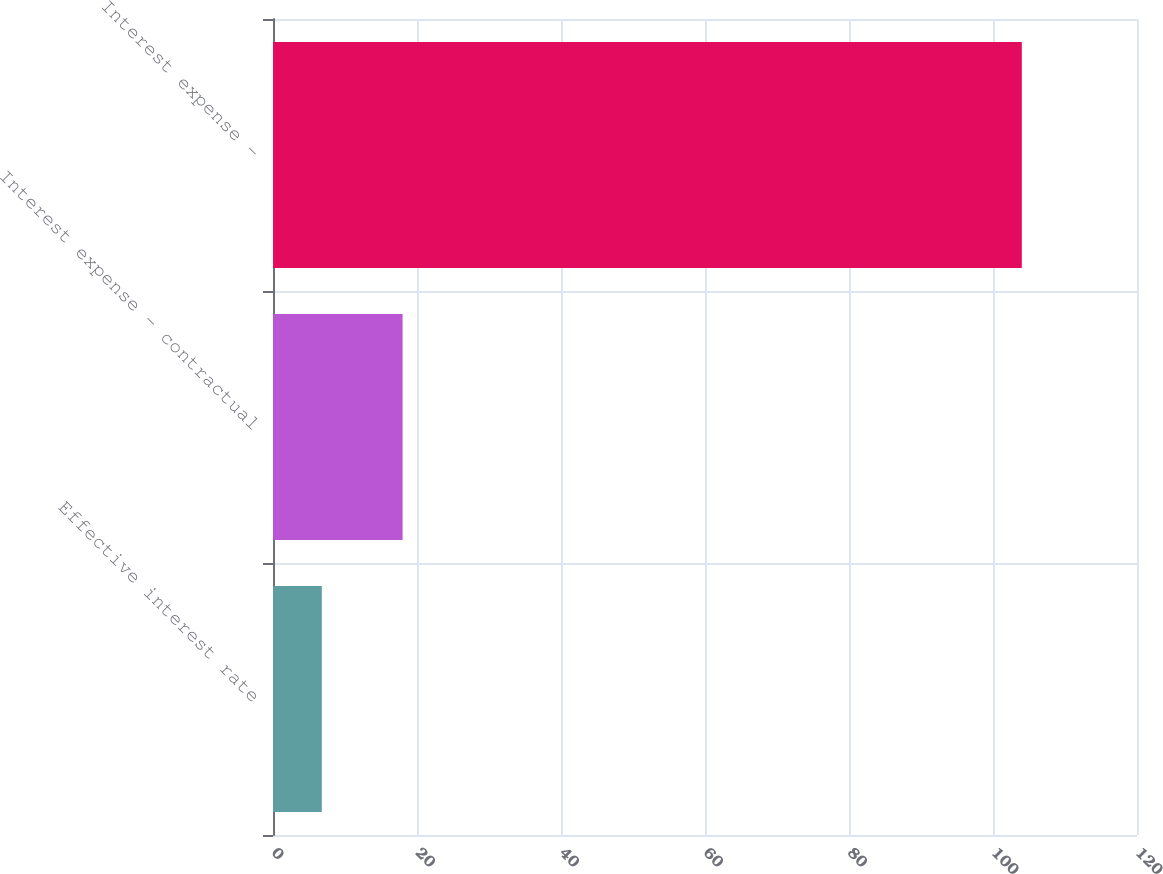<chart> <loc_0><loc_0><loc_500><loc_500><bar_chart><fcel>Effective interest rate<fcel>Interest expense - contractual<fcel>Interest expense -<nl><fcel>6.78<fcel>18<fcel>104<nl></chart> 